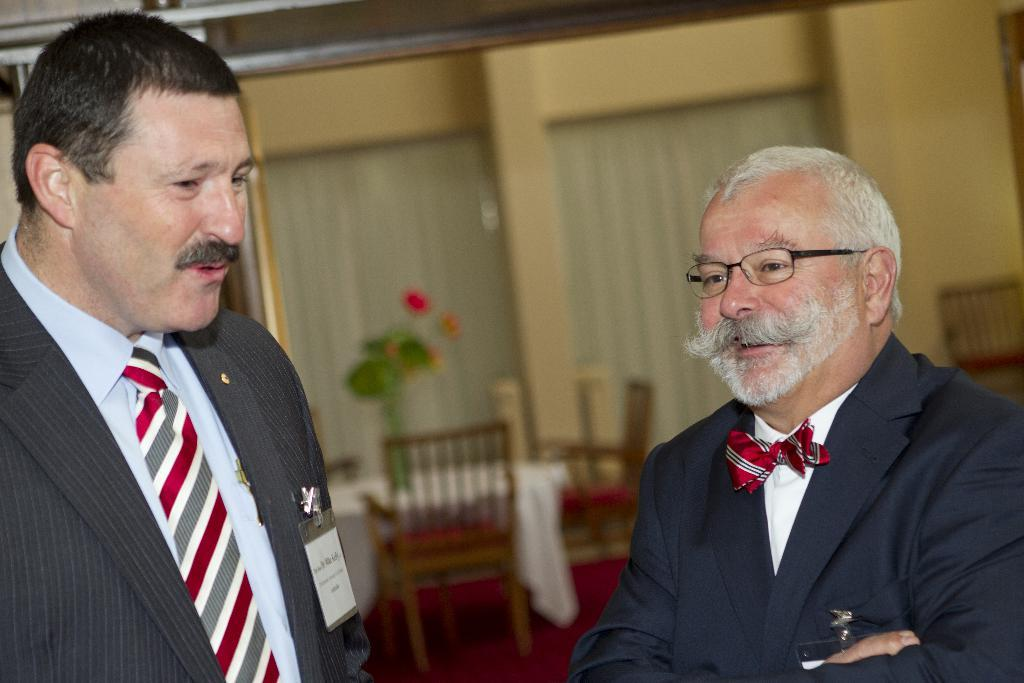Who or what is present in the image? There are people in the image. What is the facial expression of the people in the image? The people are smiling. What type of furniture is visible in the image? There are chairs visible in the image. Is there any greenery or plant life in the image? Yes, there is a flower pot in the image. What type of pot is visible on the back of the people in the image? There is no pot visible on the back of the people in the image. The flower pot mentioned in the facts is not on the back of anyone, but rather in the image. 